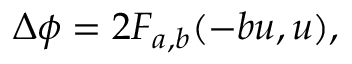Convert formula to latex. <formula><loc_0><loc_0><loc_500><loc_500>\begin{array} { r } { \Delta \phi = 2 F _ { a , b } ( - b u , u ) , } \end{array}</formula> 